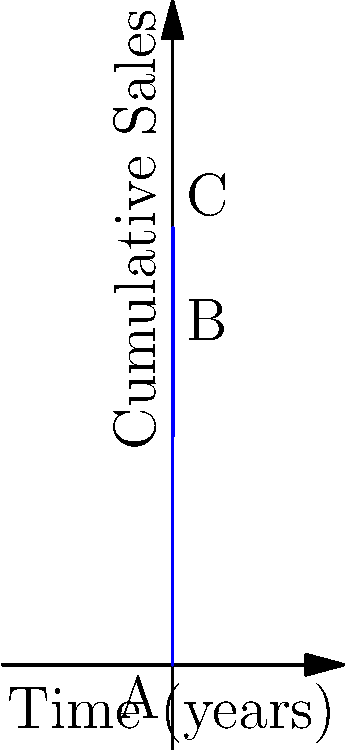As an independent musician, you've been tracking your cumulative album sales over time. The graph above represents your sales trajectory, where the curve from A to B shows sales for your first album over 3 years, and the curve from B to C represents sales including your second album release. If the area under the curve represents total revenue (assuming $1 per album sold), calculate the total revenue generated between years 3 and 6. To solve this problem, we need to calculate the area under the curve from point B to point C. Let's break it down step-by-step:

1) The cumulative sales function for the first album is given by:
   $$f(x) = 5000(1-e^{-0.5x})$$

2) The cumulative sales function for both albums after year 3 is:
   $$g(x) = 5000(1-e^{-0.5 \cdot 3}) + 2000(1-e^{-0.5(x-3)})$$

3) To find the total revenue between years 3 and 6, we need to calculate:
   $$\int_3^6 g(x) dx - f(3)$$

4) Let's break this into parts:
   a) Calculate $f(3)$:
      $$f(3) = 5000(1-e^{-0.5 \cdot 3}) \approx 3934.69$$

   b) Calculate $\int_3^6 g(x) dx$:
      $$\begin{align}
      \int_3^6 g(x) dx &= \int_3^6 [5000(1-e^{-0.5 \cdot 3}) + 2000(1-e^{-0.5(x-3)})] dx \\
      &= 5000(1-e^{-0.5 \cdot 3})(6-3) + 2000[-2e^{-0.5(x-3)}]_3^6 \\
      &= 3934.69 \cdot 3 + 2000[-2e^{-0.5(6-3)} + 2] \\
      &\approx 11804.07 + 2000(1.1269) \\
      &\approx 14057.45
      \end{align}$$

5) Now, we can calculate the total revenue:
   $$14057.45 - 3934.69 = 10122.76$$

Therefore, the total revenue generated between years 3 and 6 is approximately $10,122.76.
Answer: $10,122.76 